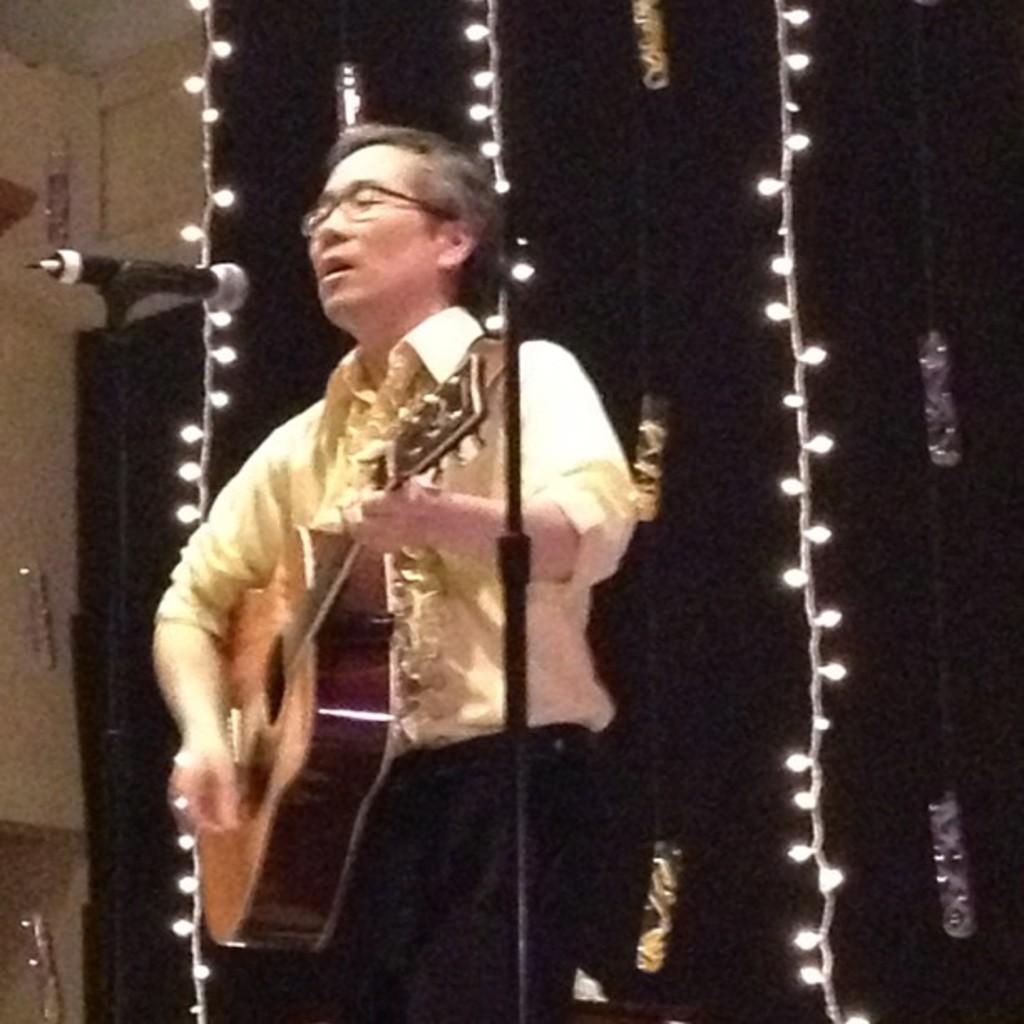Can you describe this image briefly? In this image we have a man standing and playing a guitar and singing a song in the microphone and the back ground we have lights and a cloth. 